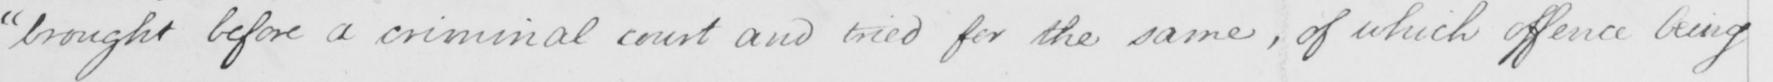What is written in this line of handwriting? " brought before a criminal court and tried for the same , of which offence being 